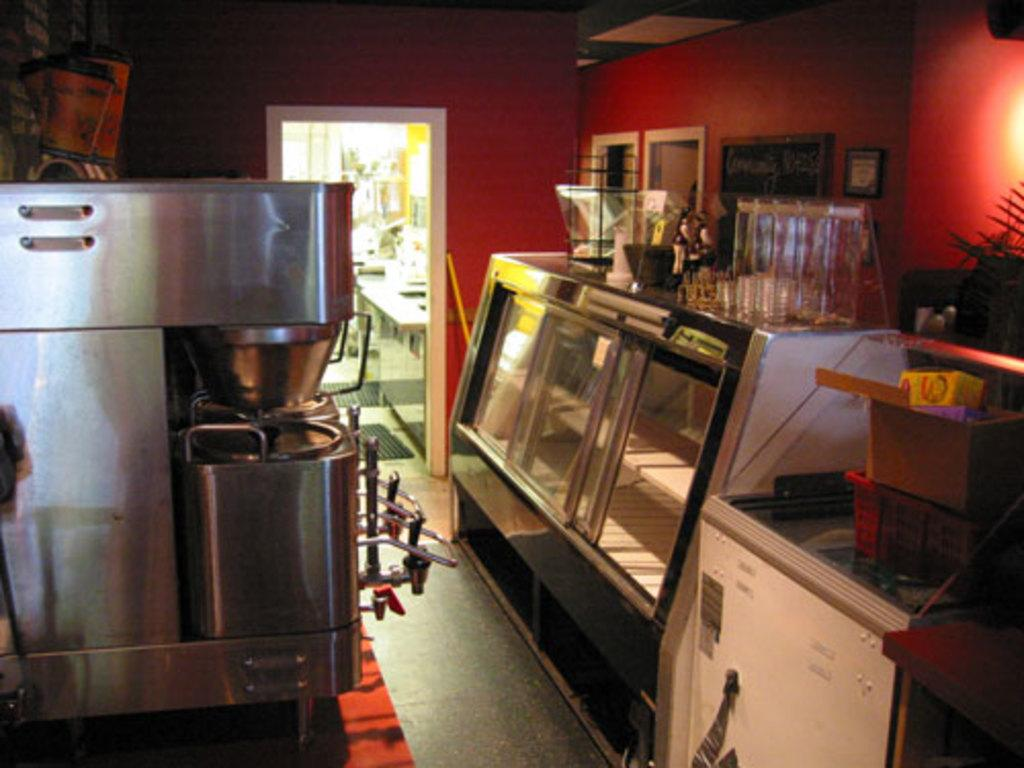What is the main structure in the image? There is a display counter in the image. Where is the display counter located in relation to other elements? The display counter is in front of a wall. What can be seen on the left side of the image? There is a machine on the left side of the image. What is located in the bottom right of the image? There is a box in the bottom right of the image. How many ants can be seen crawling on the display counter in the image? There are no ants visible in the image; the focus is on the display counter, machine, and box. What type of park is shown in the background of the image? There is no park present in the image; it features a display counter, machine, and box. 